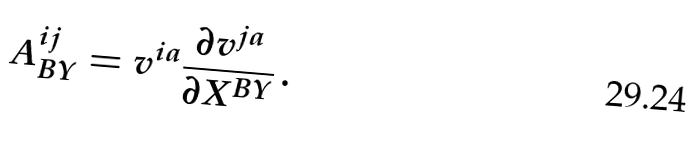<formula> <loc_0><loc_0><loc_500><loc_500>A _ { B Y } ^ { i j } = v ^ { i a } { \frac { \partial v ^ { j a } } { \partial X ^ { B Y } } } \, .</formula> 